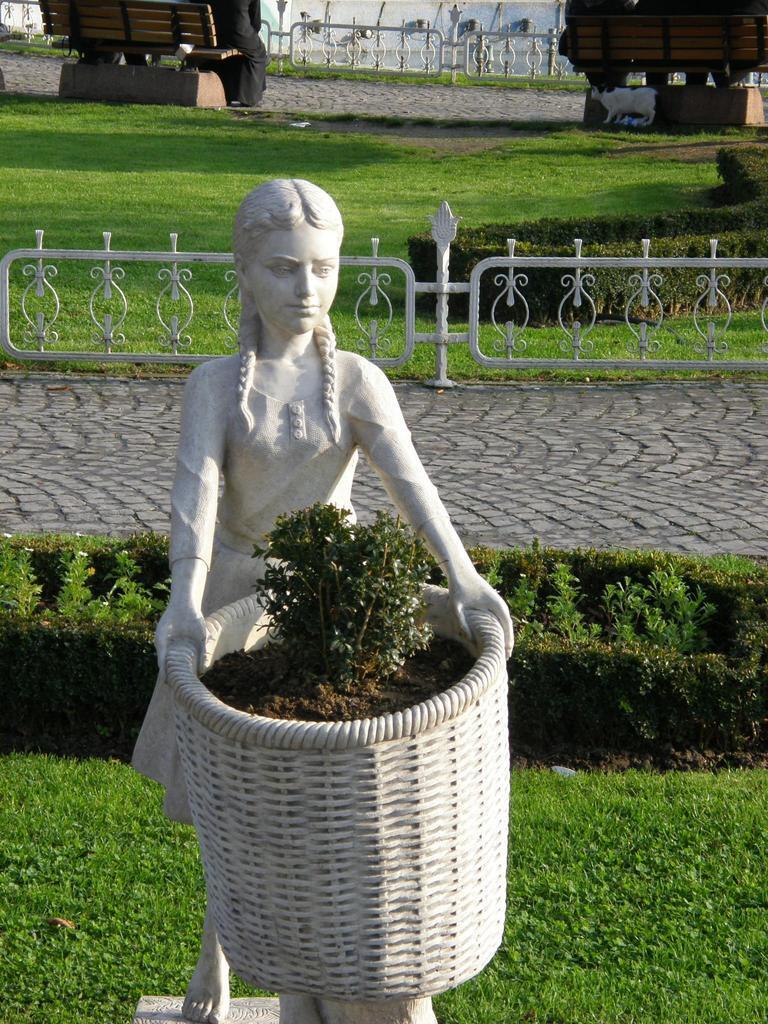Describe this image in one or two sentences. In this image we can see a potted plant and statue. Behind the statue, we can see pavement, grassy land, with fencing and benches. We can see one person is sitting on a bench and there is a cat on the grassy land. 